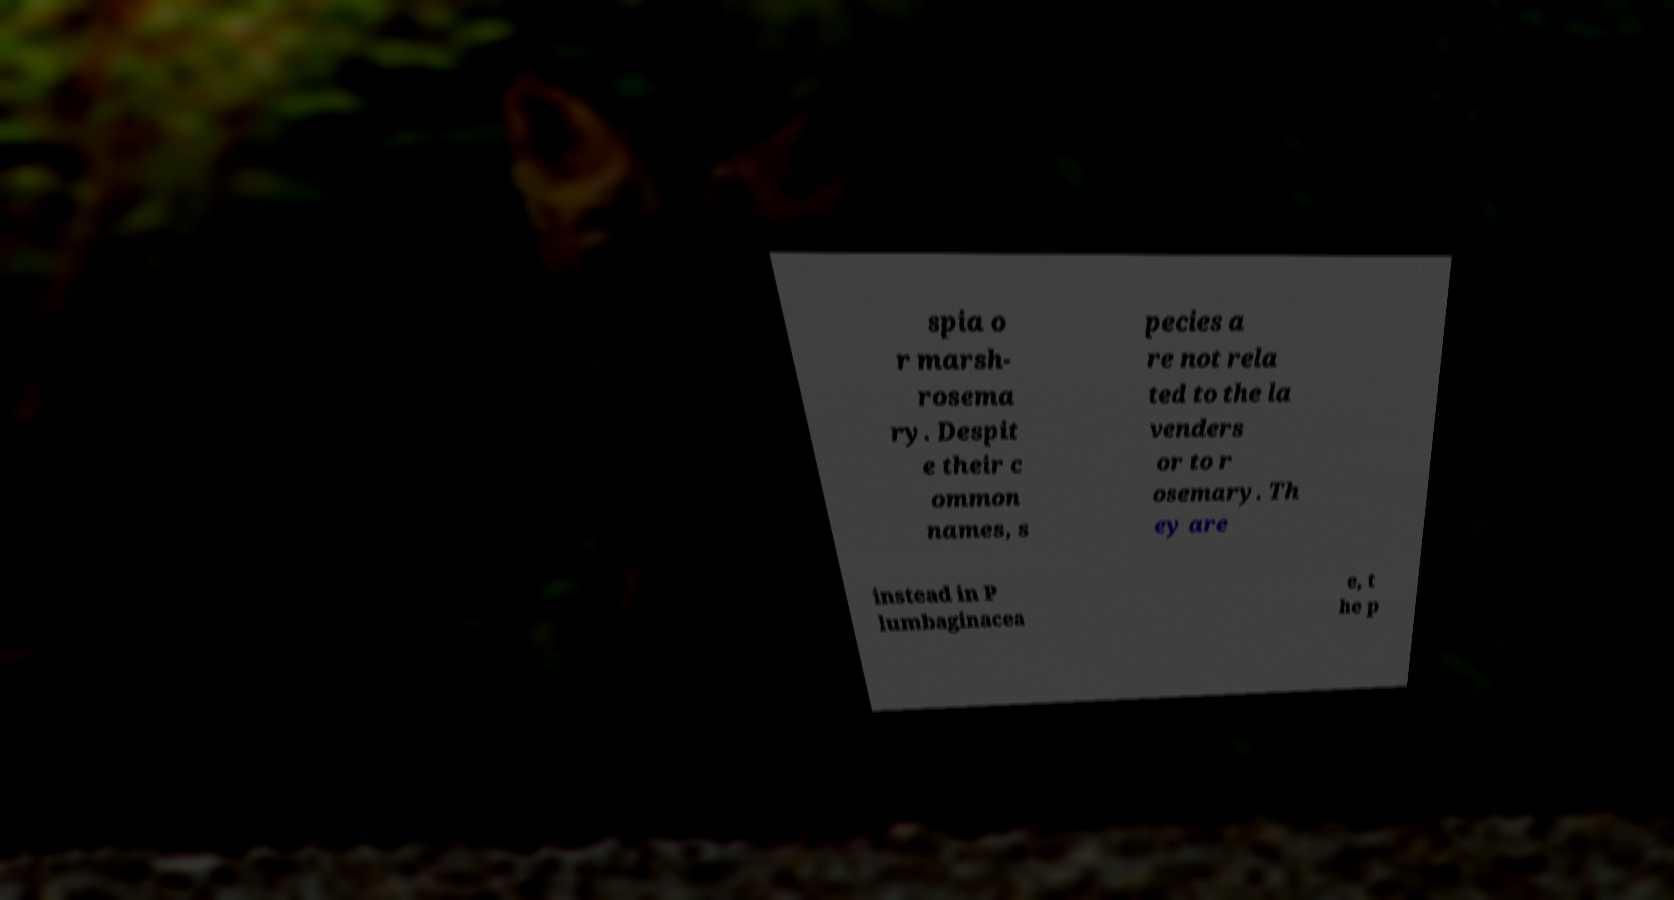Could you assist in decoding the text presented in this image and type it out clearly? spia o r marsh- rosema ry. Despit e their c ommon names, s pecies a re not rela ted to the la venders or to r osemary. Th ey are instead in P lumbaginacea e, t he p 